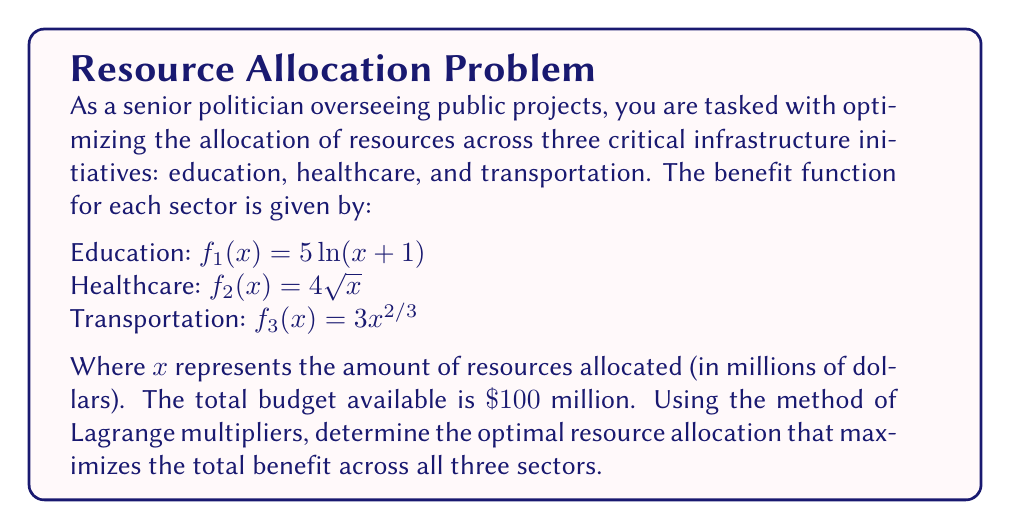Could you help me with this problem? Let's approach this step-by-step using the method of Lagrange multipliers:

1) First, we define our objective function as the sum of the benefits:
   $$F(x_1, x_2, x_3) = 5\ln(x_1+1) + 4\sqrt{x_2} + 3x_3^{2/3}$$

2) Our constraint is:
   $$g(x_1, x_2, x_3) = x_1 + x_2 + x_3 - 100 = 0$$

3) We form the Lagrangian:
   $$L(x_1, x_2, x_3, \lambda) = 5\ln(x_1+1) + 4\sqrt{x_2} + 3x_3^{2/3} - \lambda(x_1 + x_2 + x_3 - 100)$$

4) Now, we take partial derivatives and set them equal to zero:

   $$\frac{\partial L}{\partial x_1} = \frac{5}{x_1+1} - \lambda = 0$$
   $$\frac{\partial L}{\partial x_2} = \frac{2}{\sqrt{x_2}} - \lambda = 0$$
   $$\frac{\partial L}{\partial x_3} = 2x_3^{-1/3} - \lambda = 0$$
   $$\frac{\partial L}{\partial \lambda} = x_1 + x_2 + x_3 - 100 = 0$$

5) From these equations, we can derive:
   $$x_1 = \frac{5}{\lambda} - 1$$
   $$x_2 = \frac{4}{\lambda^2}$$
   $$x_3 = \left(\frac{2}{\lambda}\right)^3$$

6) Substituting these into the constraint equation:
   $$\frac{5}{\lambda} - 1 + \frac{4}{\lambda^2} + \left(\frac{2}{\lambda}\right)^3 = 100$$

7) This equation can be solved numerically to find $\lambda \approx 0.3162$.

8) Substituting this value back into our expressions for $x_1$, $x_2$, and $x_3$:
   $$x_1 \approx 14.82$$
   $$x_2 \approx 40.00$$
   $$x_3 \approx 45.18$$

Therefore, the optimal allocation is approximately:
Education: $\$14.82$ million
Healthcare: $\$40.00$ million
Transportation: $\$45.18$ million
Answer: Education: $\$14.82$ million, Healthcare: $\$40.00$ million, Transportation: $\$45.18$ million 